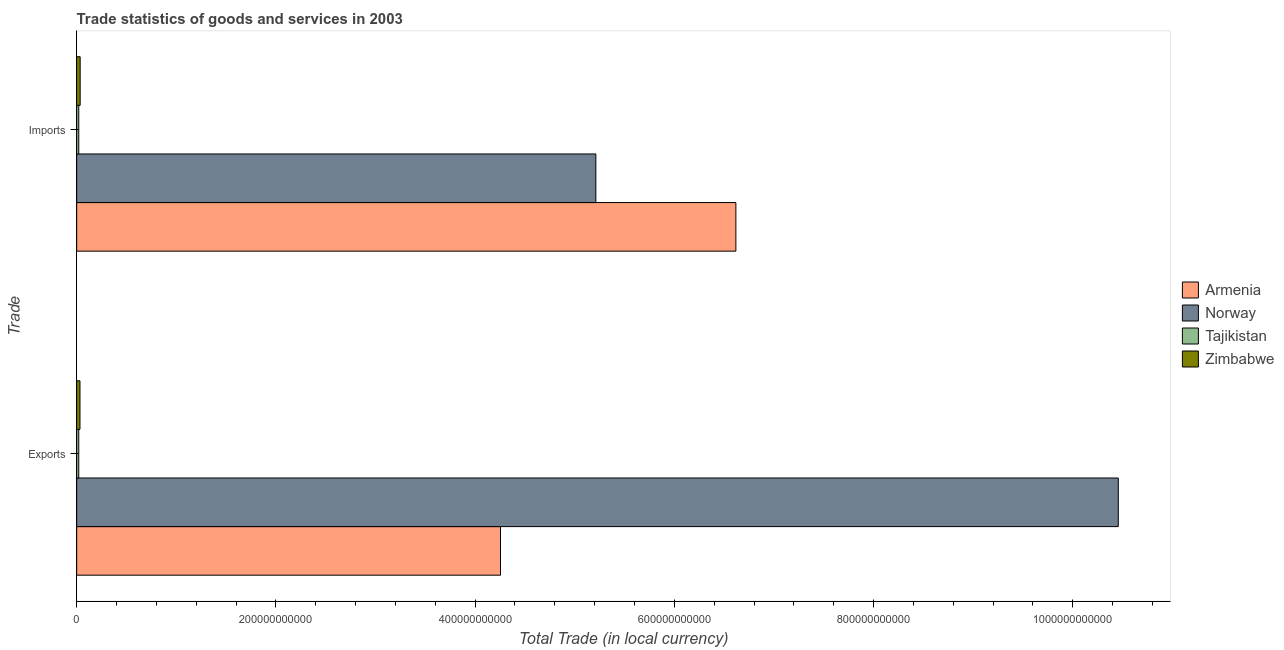Are the number of bars per tick equal to the number of legend labels?
Give a very brief answer. Yes. Are the number of bars on each tick of the Y-axis equal?
Ensure brevity in your answer.  Yes. How many bars are there on the 1st tick from the top?
Offer a terse response. 4. What is the label of the 1st group of bars from the top?
Your answer should be compact. Imports. What is the imports of goods and services in Tajikistan?
Offer a terse response. 2.12e+09. Across all countries, what is the maximum imports of goods and services?
Offer a terse response. 6.62e+11. Across all countries, what is the minimum export of goods and services?
Your answer should be very brief. 2.10e+09. In which country was the imports of goods and services maximum?
Provide a succinct answer. Armenia. In which country was the export of goods and services minimum?
Keep it short and to the point. Tajikistan. What is the total export of goods and services in the graph?
Your response must be concise. 1.48e+12. What is the difference between the imports of goods and services in Zimbabwe and that in Tajikistan?
Your answer should be compact. 1.39e+09. What is the difference between the imports of goods and services in Armenia and the export of goods and services in Tajikistan?
Provide a short and direct response. 6.60e+11. What is the average imports of goods and services per country?
Provide a short and direct response. 2.97e+11. What is the difference between the export of goods and services and imports of goods and services in Zimbabwe?
Your answer should be very brief. -1.77e+08. What is the ratio of the export of goods and services in Armenia to that in Tajikistan?
Keep it short and to the point. 202.37. Is the export of goods and services in Armenia less than that in Zimbabwe?
Ensure brevity in your answer.  No. What does the 2nd bar from the top in Imports represents?
Your response must be concise. Tajikistan. What does the 3rd bar from the bottom in Exports represents?
Make the answer very short. Tajikistan. How many bars are there?
Your answer should be compact. 8. How many countries are there in the graph?
Offer a terse response. 4. What is the difference between two consecutive major ticks on the X-axis?
Your answer should be very brief. 2.00e+11. Does the graph contain grids?
Provide a short and direct response. No. Where does the legend appear in the graph?
Offer a very short reply. Center right. What is the title of the graph?
Your answer should be compact. Trade statistics of goods and services in 2003. What is the label or title of the X-axis?
Provide a succinct answer. Total Trade (in local currency). What is the label or title of the Y-axis?
Provide a succinct answer. Trade. What is the Total Trade (in local currency) in Armenia in Exports?
Your response must be concise. 4.25e+11. What is the Total Trade (in local currency) in Norway in Exports?
Provide a short and direct response. 1.05e+12. What is the Total Trade (in local currency) in Tajikistan in Exports?
Your response must be concise. 2.10e+09. What is the Total Trade (in local currency) of Zimbabwe in Exports?
Keep it short and to the point. 3.33e+09. What is the Total Trade (in local currency) in Armenia in Imports?
Ensure brevity in your answer.  6.62e+11. What is the Total Trade (in local currency) of Norway in Imports?
Your response must be concise. 5.21e+11. What is the Total Trade (in local currency) in Tajikistan in Imports?
Your response must be concise. 2.12e+09. What is the Total Trade (in local currency) in Zimbabwe in Imports?
Your answer should be compact. 3.50e+09. Across all Trade, what is the maximum Total Trade (in local currency) in Armenia?
Offer a very short reply. 6.62e+11. Across all Trade, what is the maximum Total Trade (in local currency) of Norway?
Offer a terse response. 1.05e+12. Across all Trade, what is the maximum Total Trade (in local currency) of Tajikistan?
Ensure brevity in your answer.  2.12e+09. Across all Trade, what is the maximum Total Trade (in local currency) of Zimbabwe?
Make the answer very short. 3.50e+09. Across all Trade, what is the minimum Total Trade (in local currency) in Armenia?
Keep it short and to the point. 4.25e+11. Across all Trade, what is the minimum Total Trade (in local currency) in Norway?
Your answer should be compact. 5.21e+11. Across all Trade, what is the minimum Total Trade (in local currency) of Tajikistan?
Your answer should be very brief. 2.10e+09. Across all Trade, what is the minimum Total Trade (in local currency) of Zimbabwe?
Your response must be concise. 3.33e+09. What is the total Total Trade (in local currency) of Armenia in the graph?
Your answer should be very brief. 1.09e+12. What is the total Total Trade (in local currency) of Norway in the graph?
Give a very brief answer. 1.57e+12. What is the total Total Trade (in local currency) in Tajikistan in the graph?
Your answer should be very brief. 4.22e+09. What is the total Total Trade (in local currency) in Zimbabwe in the graph?
Your answer should be compact. 6.83e+09. What is the difference between the Total Trade (in local currency) in Armenia in Exports and that in Imports?
Provide a succinct answer. -2.36e+11. What is the difference between the Total Trade (in local currency) in Norway in Exports and that in Imports?
Provide a succinct answer. 5.24e+11. What is the difference between the Total Trade (in local currency) of Tajikistan in Exports and that in Imports?
Make the answer very short. -1.62e+07. What is the difference between the Total Trade (in local currency) in Zimbabwe in Exports and that in Imports?
Your answer should be very brief. -1.77e+08. What is the difference between the Total Trade (in local currency) of Armenia in Exports and the Total Trade (in local currency) of Norway in Imports?
Give a very brief answer. -9.57e+1. What is the difference between the Total Trade (in local currency) of Armenia in Exports and the Total Trade (in local currency) of Tajikistan in Imports?
Keep it short and to the point. 4.23e+11. What is the difference between the Total Trade (in local currency) of Armenia in Exports and the Total Trade (in local currency) of Zimbabwe in Imports?
Your response must be concise. 4.22e+11. What is the difference between the Total Trade (in local currency) in Norway in Exports and the Total Trade (in local currency) in Tajikistan in Imports?
Your response must be concise. 1.04e+12. What is the difference between the Total Trade (in local currency) in Norway in Exports and the Total Trade (in local currency) in Zimbabwe in Imports?
Provide a short and direct response. 1.04e+12. What is the difference between the Total Trade (in local currency) in Tajikistan in Exports and the Total Trade (in local currency) in Zimbabwe in Imports?
Your answer should be very brief. -1.40e+09. What is the average Total Trade (in local currency) in Armenia per Trade?
Ensure brevity in your answer.  5.44e+11. What is the average Total Trade (in local currency) of Norway per Trade?
Offer a very short reply. 7.83e+11. What is the average Total Trade (in local currency) of Tajikistan per Trade?
Your answer should be very brief. 2.11e+09. What is the average Total Trade (in local currency) in Zimbabwe per Trade?
Your answer should be very brief. 3.42e+09. What is the difference between the Total Trade (in local currency) in Armenia and Total Trade (in local currency) in Norway in Exports?
Your answer should be very brief. -6.20e+11. What is the difference between the Total Trade (in local currency) of Armenia and Total Trade (in local currency) of Tajikistan in Exports?
Offer a very short reply. 4.23e+11. What is the difference between the Total Trade (in local currency) in Armenia and Total Trade (in local currency) in Zimbabwe in Exports?
Ensure brevity in your answer.  4.22e+11. What is the difference between the Total Trade (in local currency) of Norway and Total Trade (in local currency) of Tajikistan in Exports?
Make the answer very short. 1.04e+12. What is the difference between the Total Trade (in local currency) in Norway and Total Trade (in local currency) in Zimbabwe in Exports?
Make the answer very short. 1.04e+12. What is the difference between the Total Trade (in local currency) in Tajikistan and Total Trade (in local currency) in Zimbabwe in Exports?
Offer a terse response. -1.22e+09. What is the difference between the Total Trade (in local currency) in Armenia and Total Trade (in local currency) in Norway in Imports?
Your answer should be compact. 1.41e+11. What is the difference between the Total Trade (in local currency) of Armenia and Total Trade (in local currency) of Tajikistan in Imports?
Keep it short and to the point. 6.60e+11. What is the difference between the Total Trade (in local currency) in Armenia and Total Trade (in local currency) in Zimbabwe in Imports?
Your answer should be very brief. 6.58e+11. What is the difference between the Total Trade (in local currency) of Norway and Total Trade (in local currency) of Tajikistan in Imports?
Keep it short and to the point. 5.19e+11. What is the difference between the Total Trade (in local currency) in Norway and Total Trade (in local currency) in Zimbabwe in Imports?
Your answer should be compact. 5.18e+11. What is the difference between the Total Trade (in local currency) in Tajikistan and Total Trade (in local currency) in Zimbabwe in Imports?
Ensure brevity in your answer.  -1.39e+09. What is the ratio of the Total Trade (in local currency) in Armenia in Exports to that in Imports?
Your response must be concise. 0.64. What is the ratio of the Total Trade (in local currency) of Norway in Exports to that in Imports?
Your answer should be very brief. 2.01. What is the ratio of the Total Trade (in local currency) in Tajikistan in Exports to that in Imports?
Your answer should be compact. 0.99. What is the ratio of the Total Trade (in local currency) of Zimbabwe in Exports to that in Imports?
Give a very brief answer. 0.95. What is the difference between the highest and the second highest Total Trade (in local currency) in Armenia?
Give a very brief answer. 2.36e+11. What is the difference between the highest and the second highest Total Trade (in local currency) of Norway?
Ensure brevity in your answer.  5.24e+11. What is the difference between the highest and the second highest Total Trade (in local currency) of Tajikistan?
Give a very brief answer. 1.62e+07. What is the difference between the highest and the second highest Total Trade (in local currency) in Zimbabwe?
Ensure brevity in your answer.  1.77e+08. What is the difference between the highest and the lowest Total Trade (in local currency) of Armenia?
Provide a short and direct response. 2.36e+11. What is the difference between the highest and the lowest Total Trade (in local currency) of Norway?
Provide a succinct answer. 5.24e+11. What is the difference between the highest and the lowest Total Trade (in local currency) in Tajikistan?
Keep it short and to the point. 1.62e+07. What is the difference between the highest and the lowest Total Trade (in local currency) of Zimbabwe?
Offer a very short reply. 1.77e+08. 